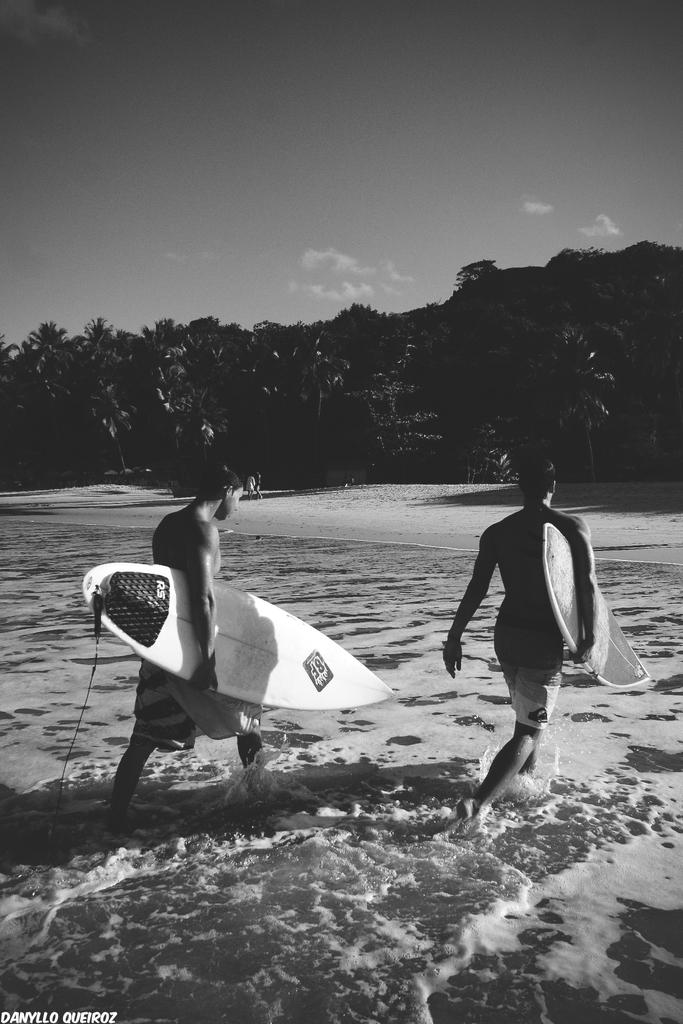How many people are in the image? There are two men in the image. What are the men carrying in the image? The men are carrying ski boards. Where are the men located in the image? The men are in the water. What type of terrain can be seen in the background of the image? There is sand visible in the background of the image. What else can be seen in the background of the image? There are trees and the sky visible in the background of the image. What type of stamp can be seen on the men's ski boards in the image? There is no stamp visible on the men's ski boards in the image. What type of muscle is being exercised by the men in the image? The image does not show the men exercising any specific muscles; they are simply carrying ski boards in the water. 